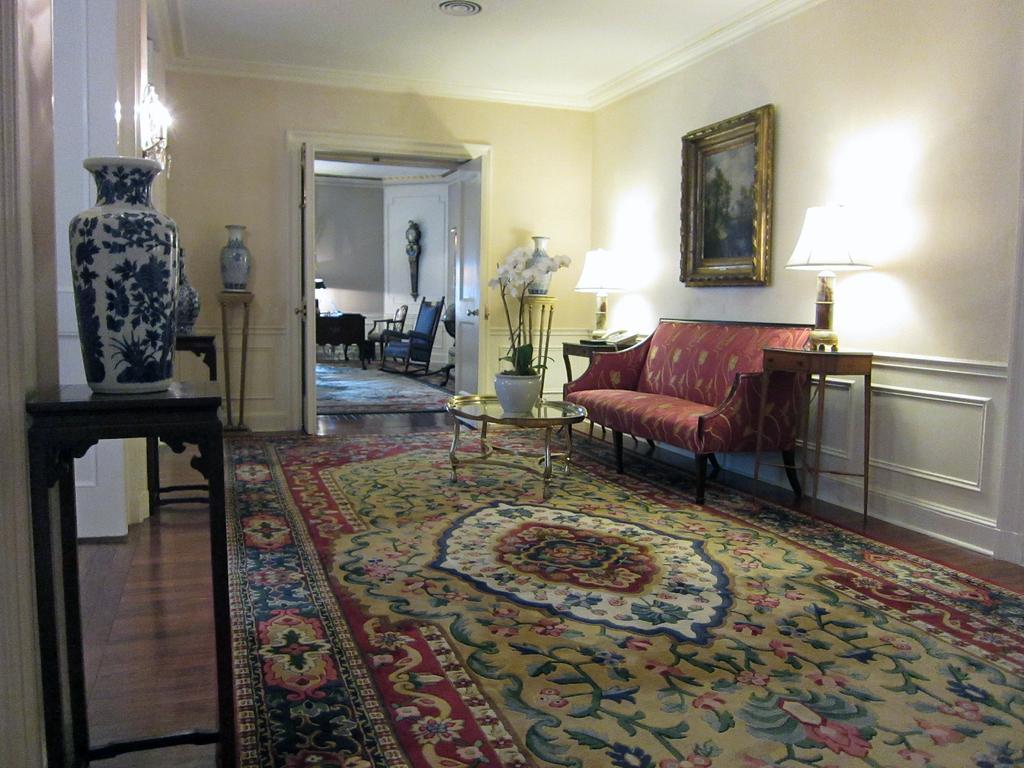Describe this image in one or two sentences. In this image I can see a table with a flower pot placed on it. This is a carpet with design on it. This is a teapoy and I can see a white pot placed on the teapoy. This is a couch. I can see tables beside couch. On this I can see telephone and lamp placed on the table. This is a photo frame which is attached to the wall. At background I can see a room with chairs and some object is changed to the wall. This is another table with flower vase on it. 